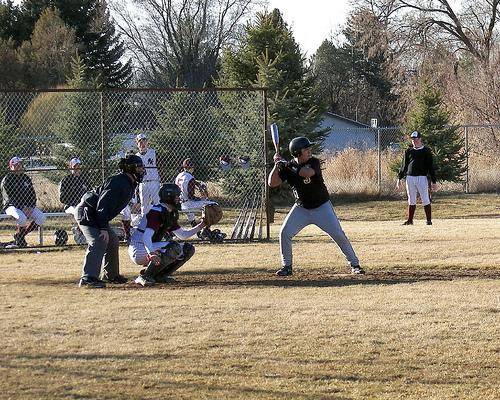Analyze the interaction between the batter and the catcher in the image. The batter is focused on the pitch, preparing to swing, while the catcher is concentrating on catching the pitch. What kind of sentiment or mood can be inferred from the image? The sentiment can be described as intense and focused, due to the concentration of the players on the pitch. Provide a brief description of the scene in the image, focusing on the main action taking place. A baseball player is preparing to swing a bat, with an umpire and a catcher in position, all surrounded by a fence. What is the primary object in the image doing? A baseball player is getting ready to swing a bat. What action is the umpire performing in the image? awaiting the pitch Identify the location of the shin guards in the image. on the catcher's legs Express the unhurried anticipation experienced by the umpire and the catcher as they await the pitch. In the stillness of the moment, the umpire and catcher hold their breath, eyes locked on the pitcher, sensing the imminent release of a fast, powerful throw. Describe the weather conditions in the background of the image. cloudy sky Determine the activity being performed by the baseball player with the bat. getting ready to swing the bat What object is behind the batter, and what items are leaning against it? metal fence is behind the batter, five bats are leaning against it Based on their attire and position, infer what the individuals sitting on the bench are likely doing. watching the baseball game Select the accurate statement: a) The metal fence is behind the umpire, b) The metal fence is in front of the batter, c) The metal fence is behind the batter. c) The metal fence is behind the batter Choose the correct statement: a) The umpire is wearing a helmet, b) The umpire is wearing a cap, c) The umpire is wearing a hat. a) The umpire is wearing a helmet Who is wearing a long-sleeved uniform for keeping warm in the image? player on the sidelines Which object offers head protection for the batter? baseball batters helmet What is the role of the person standing behind the catcher and the umpire? baseball referee How do the baseball players on the bench interact with the game? they are sitting and watching the game Identify the object referred to as "a dry brown grassy baseball field" present in the image. baseball field Using a poetic style, describe the baseball player who is getting ready for the pitch. Under the vast, cloud-laden sky, a focused warrior stands clad in black and grey, gripping his wooden sword and anticipating the coming challenge. What is the function of the catcher's equipment, such as the mask and shin guards? protection against hard pitches and low pitches Who is holding a baseball bat? baseball player Identify the color of the shirt worn by the batter, the color of his helmet, and the color of his pants. shirt is black, helmet is black, pants are grey Describe the scene visible in the image, including the main objects, their actions, and the background features. baseball player holding bat and concentrating on the pitch, umpire and catcher awaiting the pitch, spare bats leaning on metal fence, bench with players watching, trees and cloudy sky in background 